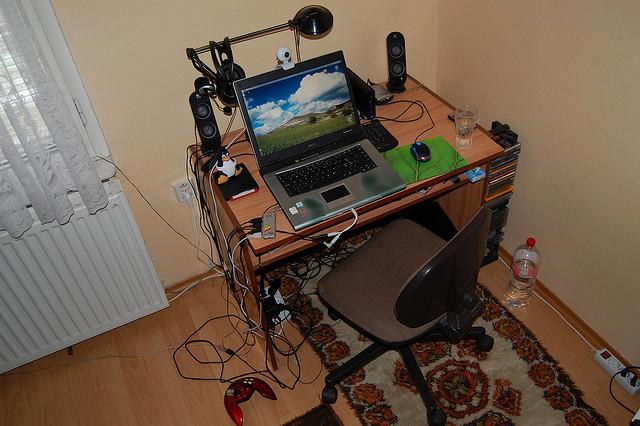Where are the wheels?
Be succinct. On chair. What color is the curtain?
Be succinct. White. What is on the desk?
Be succinct. Laptop. Are the curtains open?
Concise answer only. No. How many monitors can be seen?
Keep it brief. 1. What is the title of the green book?
Be succinct. No book. What color is the game controller on the floor?
Quick response, please. Red. What room are they in?
Keep it brief. Office. Is the wall dirty?
Give a very brief answer. No. Why is the computer on?
Give a very brief answer. Someone was using it. What material covers the floor?
Write a very short answer. Hardwood. 